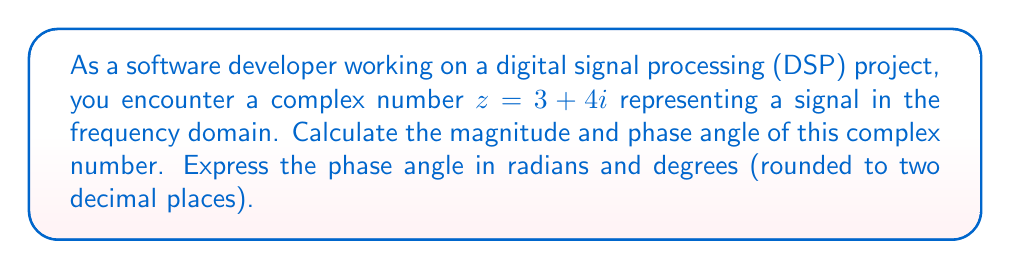What is the answer to this math problem? To calculate the magnitude and phase of a complex number $z = a + bi$, we use the following formulas:

1. Magnitude: $|z| = \sqrt{a^2 + b^2}$
2. Phase angle (in radians): $\theta = \arctan(\frac{b}{a})$

For the given complex number $z = 3 + 4i$:

1. Magnitude calculation:
   $$|z| = \sqrt{3^2 + 4^2} = \sqrt{9 + 16} = \sqrt{25} = 5$$

2. Phase angle calculation (in radians):
   $$\theta = \arctan(\frac{4}{3}) \approx 0.9273 \text{ radians}$$

3. Converting phase angle to degrees:
   $$\theta_{\text{degrees}} = \theta_{\text{radians}} \times \frac{180°}{\pi} \approx 53.13°$$

In digital signal processing, the magnitude represents the amplitude of the signal at a particular frequency, while the phase angle represents the phase shift of the signal relative to a reference point.
Answer: Magnitude: $|z| = 5$
Phase angle: $\theta \approx 0.93$ radians or $53.13°$ 